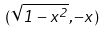<formula> <loc_0><loc_0><loc_500><loc_500>( \sqrt { 1 - x ^ { 2 } } , - x )</formula> 